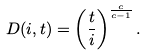Convert formula to latex. <formula><loc_0><loc_0><loc_500><loc_500>D ( i , t ) = \left ( \frac { t } { i } \right ) ^ { \frac { c } { c - 1 } } .</formula> 